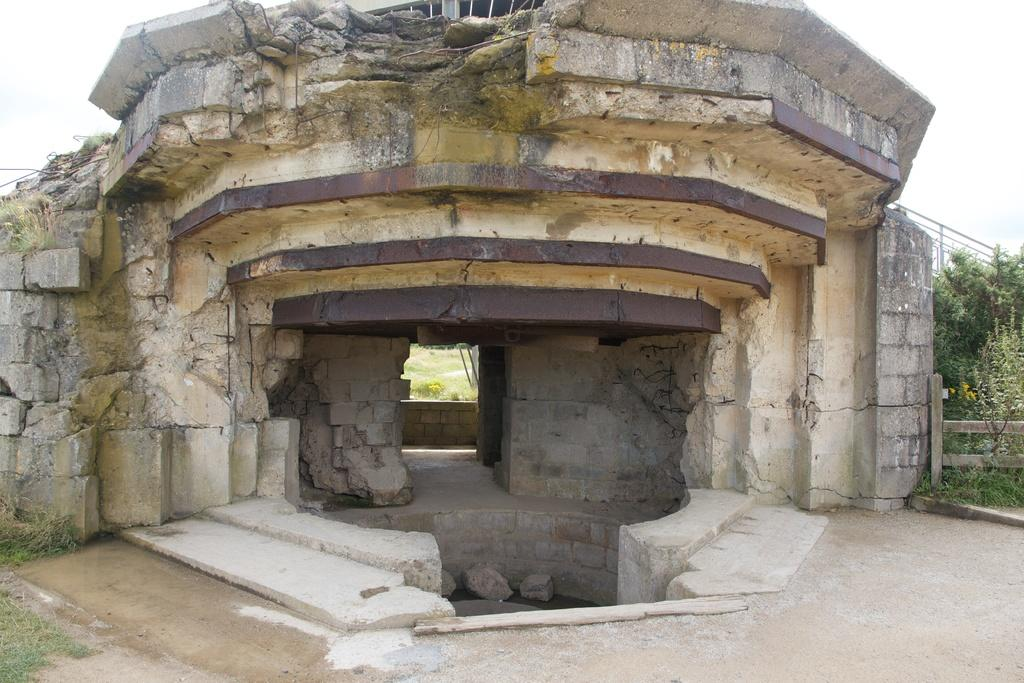What is the main subject in the image? There is a monument in the image. What type of vegetation is present in the image? There are trees and plants at the rightmost part of the image. Can you see any apples growing on the trees in the image? There is no mention of apples or any fruit trees in the image; it only features a monument and trees. Is there any quicksand visible in the image? There is no quicksand present in the image. Are there any waves visible in the image? There is no reference to waves or water bodies in the image; it only features a monument and trees. 